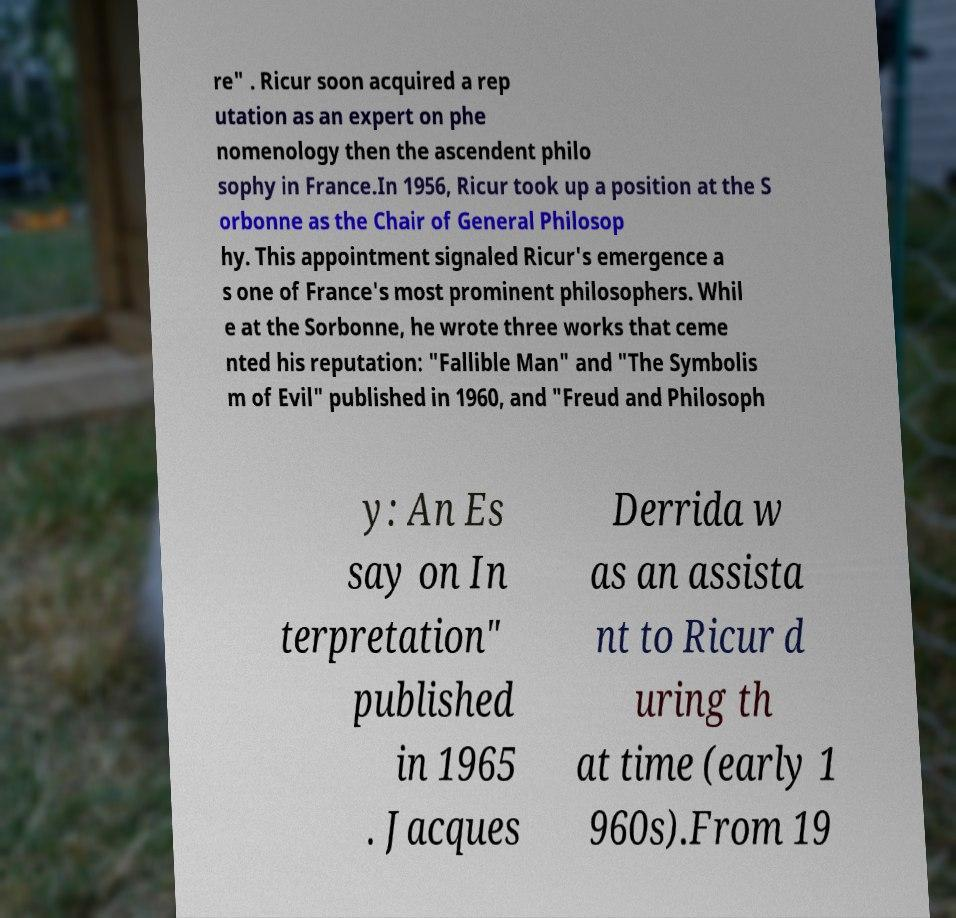I need the written content from this picture converted into text. Can you do that? re" . Ricur soon acquired a rep utation as an expert on phe nomenology then the ascendent philo sophy in France.In 1956, Ricur took up a position at the S orbonne as the Chair of General Philosop hy. This appointment signaled Ricur's emergence a s one of France's most prominent philosophers. Whil e at the Sorbonne, he wrote three works that ceme nted his reputation: "Fallible Man" and "The Symbolis m of Evil" published in 1960, and "Freud and Philosoph y: An Es say on In terpretation" published in 1965 . Jacques Derrida w as an assista nt to Ricur d uring th at time (early 1 960s).From 19 